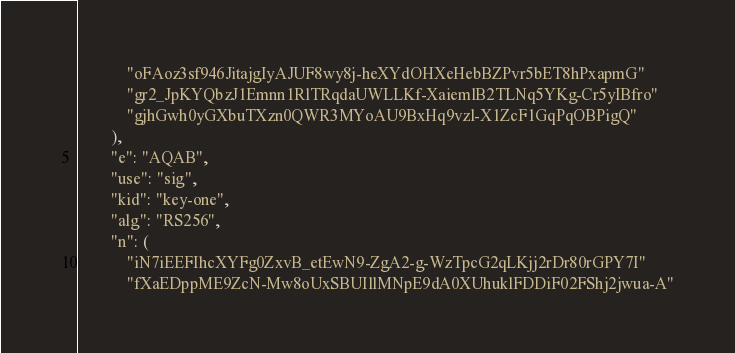Convert code to text. <code><loc_0><loc_0><loc_500><loc_500><_Python_>            "oFAoz3sf946JitajgIyAJUF8wy8j-heXYdOHXeHebBZPvr5bET8hPxapmG"
            "gr2_JpKYQbzJ1Emnn1RlTRqdaUWLLKf-XaiemlB2TLNq5YKg-Cr5yIBfro"
            "gjhGwh0yGXbuTXzn0QWR3MYoAU9BxHq9vzl-X1ZcF1GqPqOBPigQ"
        ),
        "e": "AQAB",
        "use": "sig",
        "kid": "key-one",
        "alg": "RS256",
        "n": (
            "iN7iEEFIhcXYFg0ZxvB_etEwN9-ZgA2-g-WzTpcG2qLKjj2rDr80rGPY7I"
            "fXaEDppME9ZcN-Mw8oUxSBUIllMNpE9dA0XUhuklFDDiF02FShj2jwua-A"</code> 